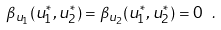<formula> <loc_0><loc_0><loc_500><loc_500>\beta _ { u _ { 1 } } ( u _ { 1 } ^ { * } , u _ { 2 } ^ { * } ) = \beta _ { u _ { 2 } } ( u _ { 1 } ^ { * } , u _ { 2 } ^ { * } ) = 0 \ .</formula> 